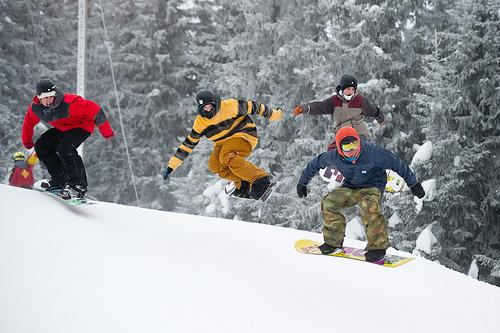What is the color of the jacket someone is wearing in the picture? A person is wearing a black and yellow jacket. Describe the environment where the people are enjoying themselves. The people are enjoying themselves at a ski resort in the mountains, surrounded by pine trees and snow. Summarize the primary emotion in the image and the reason behind it. The primary emotion in the image is happiness, as the people are having a great time snowboarding on their day off. Describe an interesting detail about the attire of one of the snowboarders. One snowboarder is wearing a shirt with stripes on it, which seems to be yellow. What type of clothing are the people in the image wearing to stay warm? People in the image are wearing warm clothing like hats, jackets, pants, and gloves. What are the different colors of snowboards mentioned in the captions? The snowboards come in two colors: yellow and blue. Identify the primary activity that is taking place in the image. Snowboarding is the main activity in the image. 